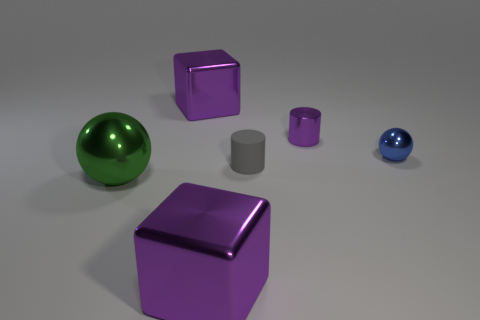Add 2 small things. How many objects exist? 8 Subtract all cubes. How many objects are left? 4 Subtract 0 green cubes. How many objects are left? 6 Subtract all gray cylinders. Subtract all cylinders. How many objects are left? 3 Add 4 purple objects. How many purple objects are left? 7 Add 5 purple objects. How many purple objects exist? 8 